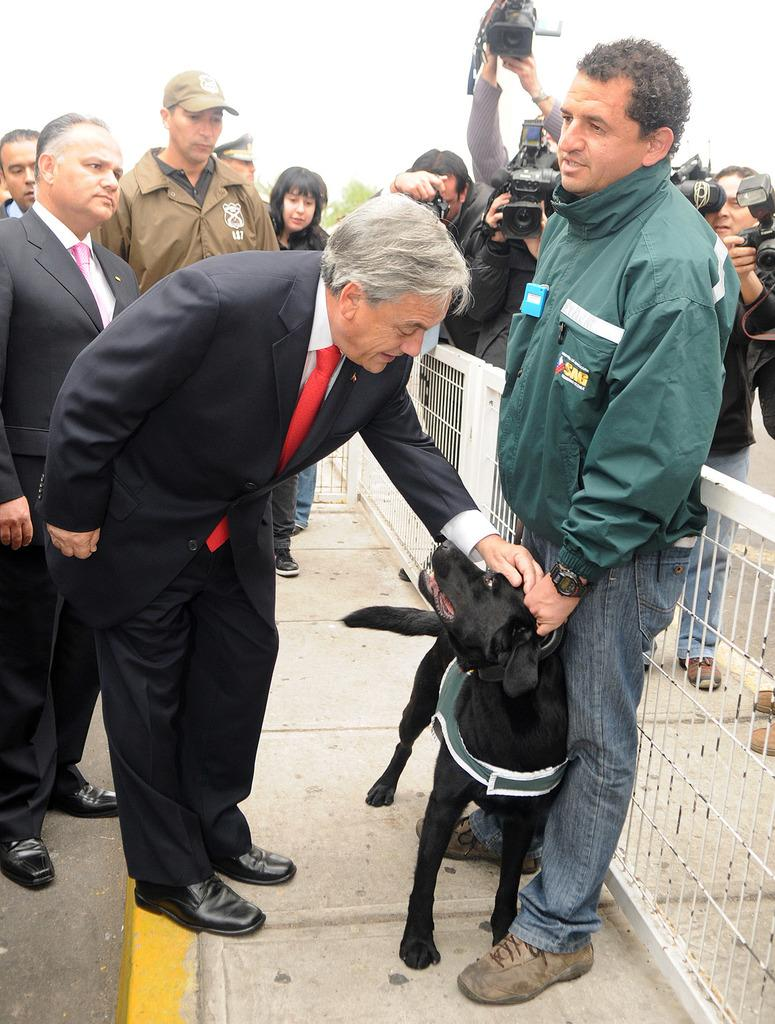What are the people in the image doing? There are persons standing on the road in the image. What other living creature can be seen in the image? There is a dog in the image. Who is holding a camera in the image? There is a man holding a camera in the image. What is visible in the background of the image? The sky is visible in the image. What type of plantation can be seen in the image? There is no plantation present in the image. How does the carpenter use his nerves in the image? There is no carpenter or mention of nerves in the image. 